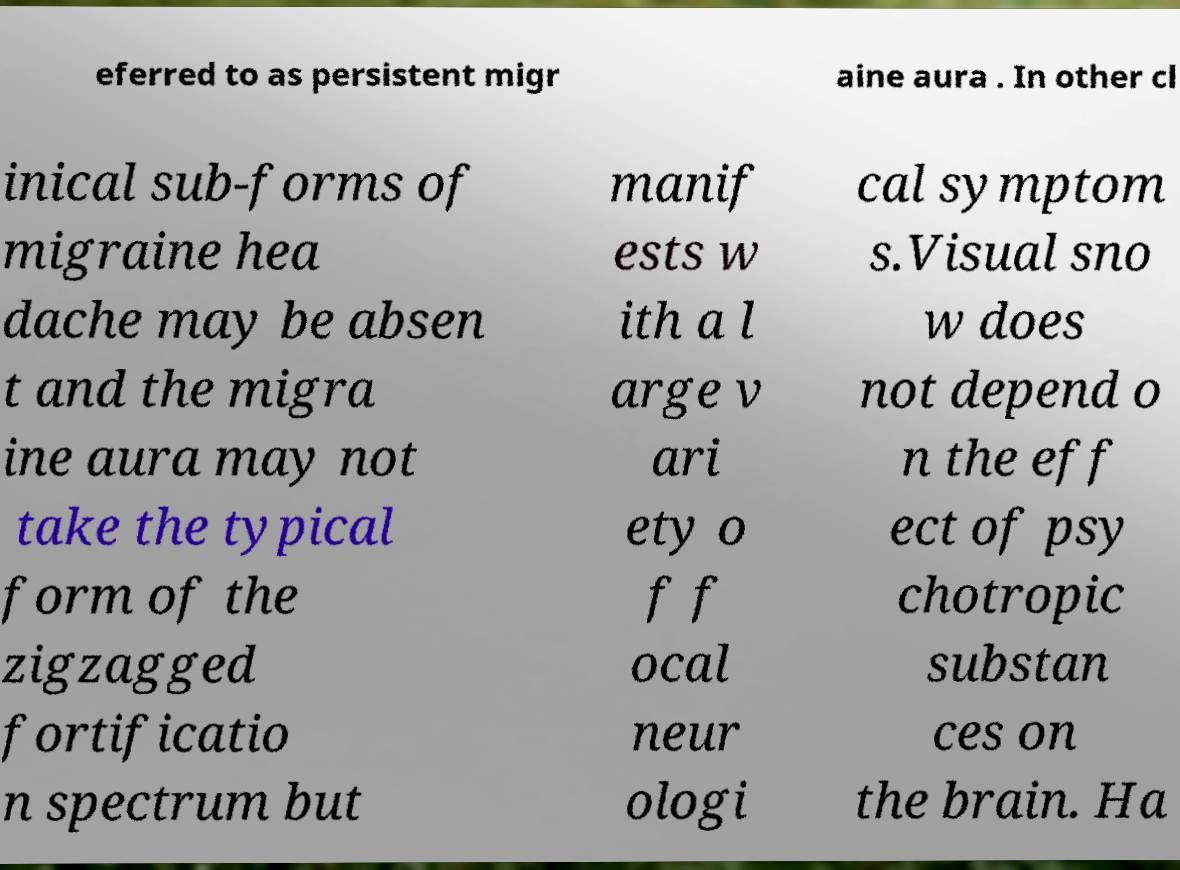For documentation purposes, I need the text within this image transcribed. Could you provide that? eferred to as persistent migr aine aura . In other cl inical sub-forms of migraine hea dache may be absen t and the migra ine aura may not take the typical form of the zigzagged fortificatio n spectrum but manif ests w ith a l arge v ari ety o f f ocal neur ologi cal symptom s.Visual sno w does not depend o n the eff ect of psy chotropic substan ces on the brain. Ha 